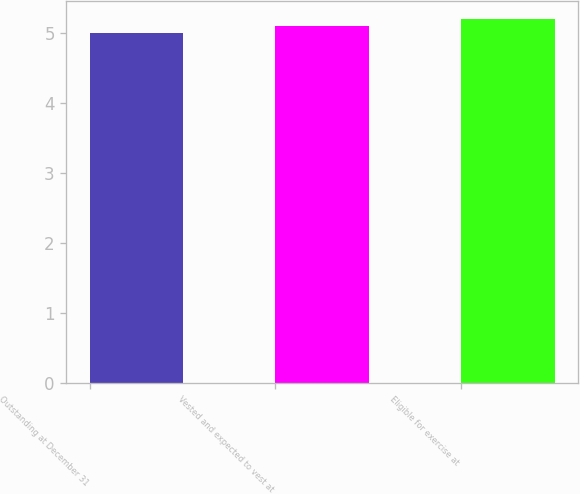Convert chart to OTSL. <chart><loc_0><loc_0><loc_500><loc_500><bar_chart><fcel>Outstanding at December 31<fcel>Vested and expected to vest at<fcel>Eligible for exercise at<nl><fcel>5<fcel>5.1<fcel>5.2<nl></chart> 